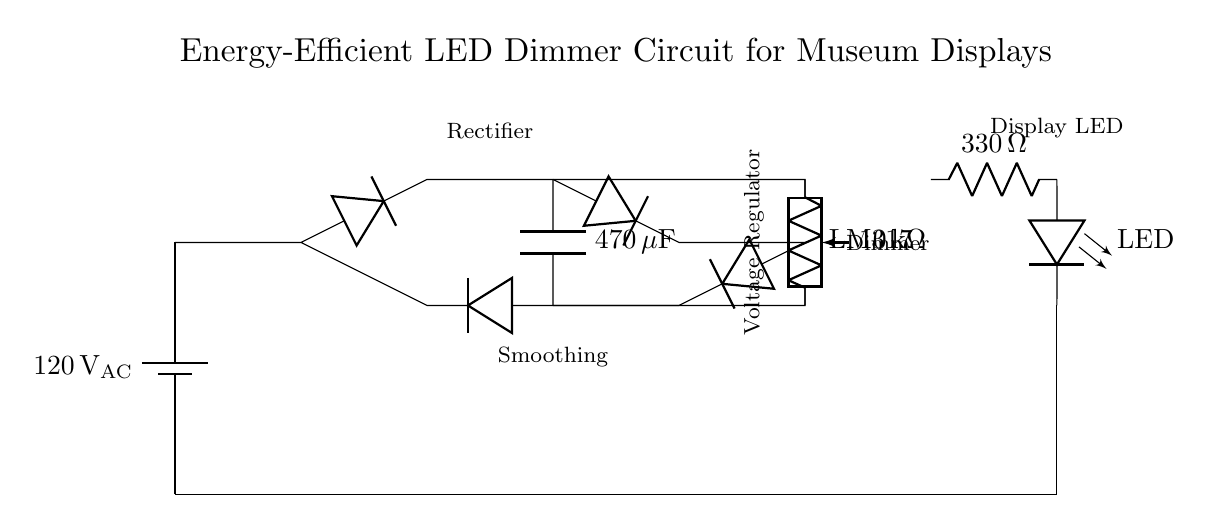What is the voltage source in this circuit? The voltage source is labeled as 120 volts AC, which is indicated next to the battery symbol at the beginning of the circuit.
Answer: 120 volts AC What is the purpose of the smoothing capacitor? The smoothing capacitor, labeled as 470 microfarads, is used to reduce voltage fluctuations after the rectifier. It filters the output of the rectifier.
Answer: Reduce voltage fluctuations What component is used for dimming the LED? The potentiometer, labeled as 10 kiloohms, is used for adjusting the brightness of the LED by varying the resistance in the circuit.
Answer: Potentiometer How many diodes are used in the rectifier bridge? There are four diodes used in the rectifier bridge as indicated by the layout, forming a bridge configuration.
Answer: Four What is the function of the current limiting resistor? The current limiting resistor, labeled as 330 ohms, is used to restrict the current flowing into the LED, preventing it from drawing too much current and getting damaged.
Answer: Restrict current to LED What voltage regulator is used in this circuit? The voltage regulator is labeled as LM317, which is a type of adjustable voltage regulator shown in the diagram.
Answer: LM317 What type of load is connected to this circuit? The load connected to this circuit is an LED, which is indicated by the LED symbol in the circuit.
Answer: LED 